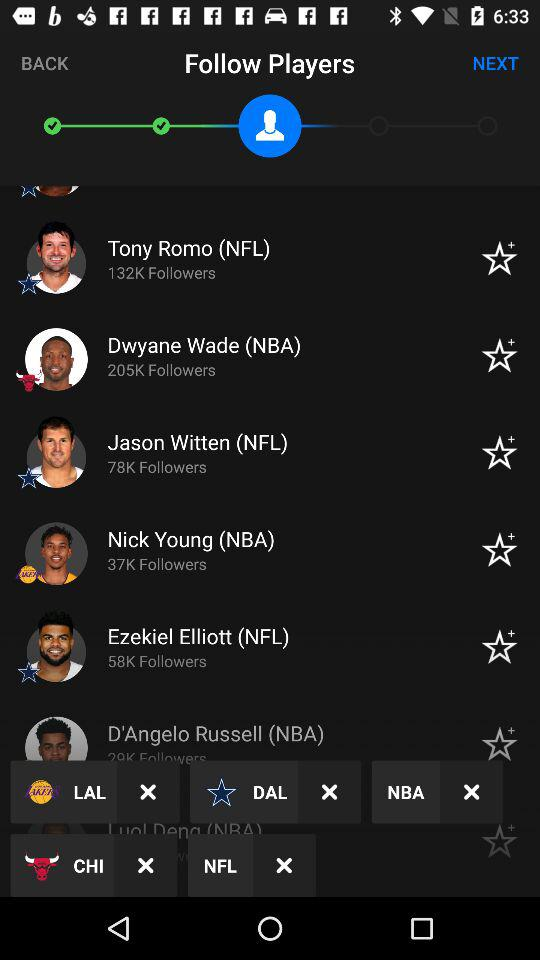How many followers of Nick Young are there? There are 37K followers of Nick Young. 